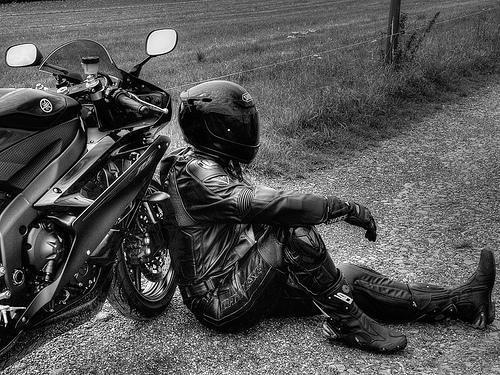How many people are pictured here?
Give a very brief answer. 1. How many vehicles appear in this picture?
Give a very brief answer. 1. 